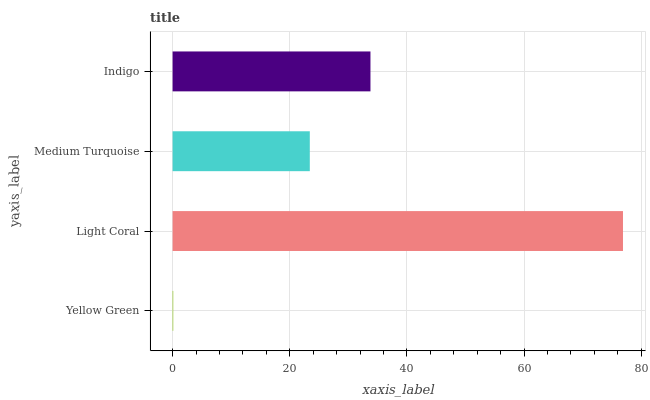Is Yellow Green the minimum?
Answer yes or no. Yes. Is Light Coral the maximum?
Answer yes or no. Yes. Is Medium Turquoise the minimum?
Answer yes or no. No. Is Medium Turquoise the maximum?
Answer yes or no. No. Is Light Coral greater than Medium Turquoise?
Answer yes or no. Yes. Is Medium Turquoise less than Light Coral?
Answer yes or no. Yes. Is Medium Turquoise greater than Light Coral?
Answer yes or no. No. Is Light Coral less than Medium Turquoise?
Answer yes or no. No. Is Indigo the high median?
Answer yes or no. Yes. Is Medium Turquoise the low median?
Answer yes or no. Yes. Is Light Coral the high median?
Answer yes or no. No. Is Yellow Green the low median?
Answer yes or no. No. 